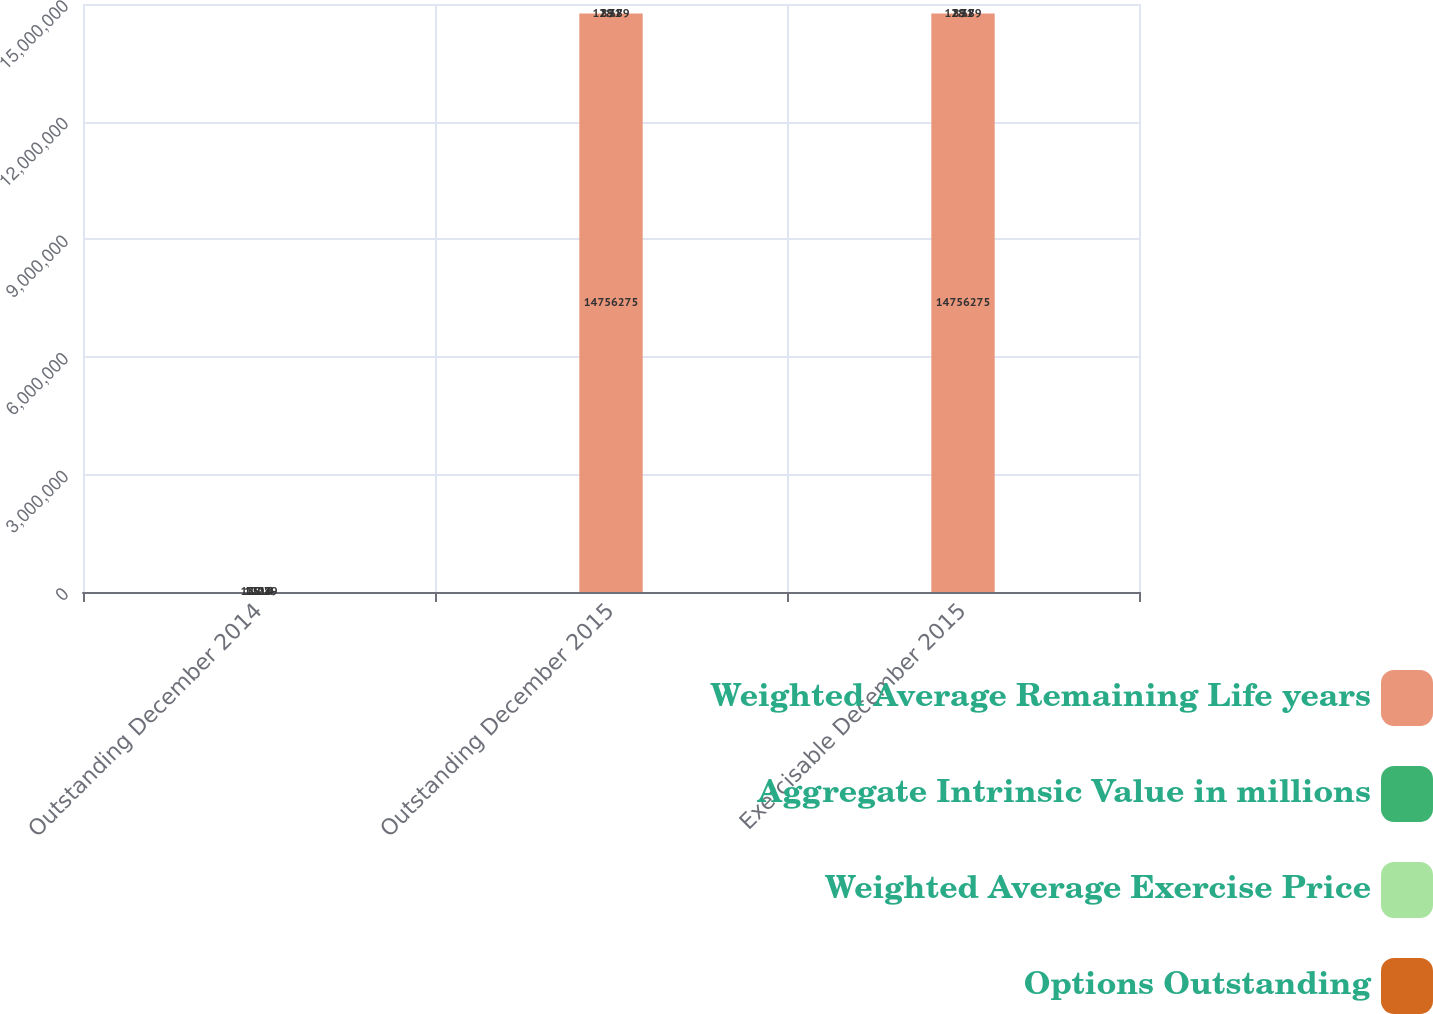Convert chart. <chart><loc_0><loc_0><loc_500><loc_500><stacked_bar_chart><ecel><fcel>Outstanding December 2014<fcel>Outstanding December 2015<fcel>Exercisable December 2015<nl><fcel>Weighted Average Remaining Life years<fcel>128.79<fcel>1.47563e+07<fcel>1.47563e+07<nl><fcel>Aggregate Intrinsic Value in millions<fcel>120.4<fcel>128.79<fcel>128.79<nl><fcel>Weighted Average Exercise Price<fcel>1516<fcel>891<fcel>891<nl><fcel>Options Outstanding<fcel>3.28<fcel>2.38<fcel>2.38<nl></chart> 